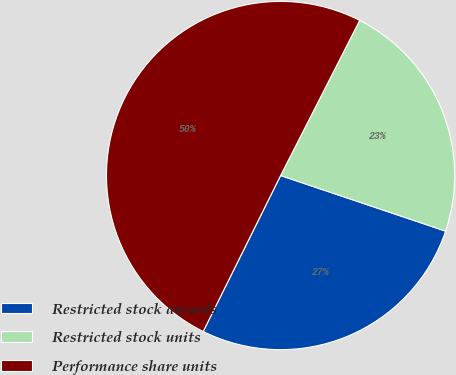Convert chart to OTSL. <chart><loc_0><loc_0><loc_500><loc_500><pie_chart><fcel>Restricted stock awards<fcel>Restricted stock units<fcel>Performance share units<nl><fcel>27.16%<fcel>22.67%<fcel>50.17%<nl></chart> 